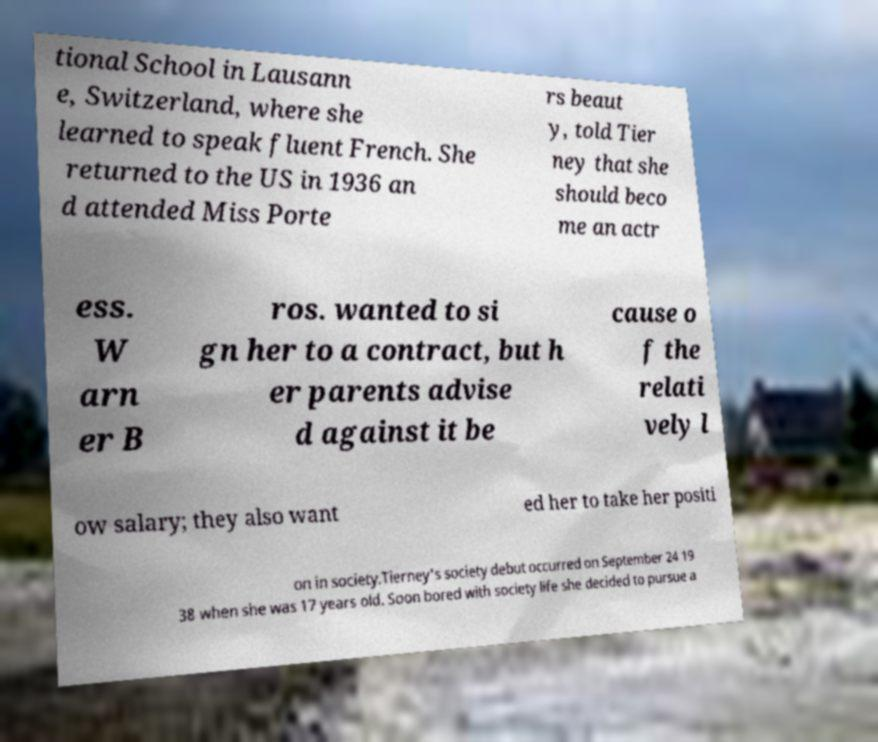Can you read and provide the text displayed in the image?This photo seems to have some interesting text. Can you extract and type it out for me? tional School in Lausann e, Switzerland, where she learned to speak fluent French. She returned to the US in 1936 an d attended Miss Porte rs beaut y, told Tier ney that she should beco me an actr ess. W arn er B ros. wanted to si gn her to a contract, but h er parents advise d against it be cause o f the relati vely l ow salary; they also want ed her to take her positi on in society.Tierney's society debut occurred on September 24 19 38 when she was 17 years old. Soon bored with society life she decided to pursue a 